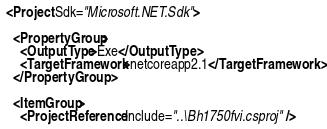Convert code to text. <code><loc_0><loc_0><loc_500><loc_500><_XML_><Project Sdk="Microsoft.NET.Sdk">

  <PropertyGroup>
    <OutputType>Exe</OutputType>
    <TargetFramework>netcoreapp2.1</TargetFramework>
  </PropertyGroup>

  <ItemGroup>
    <ProjectReference Include="..\Bh1750fvi.csproj" /></code> 